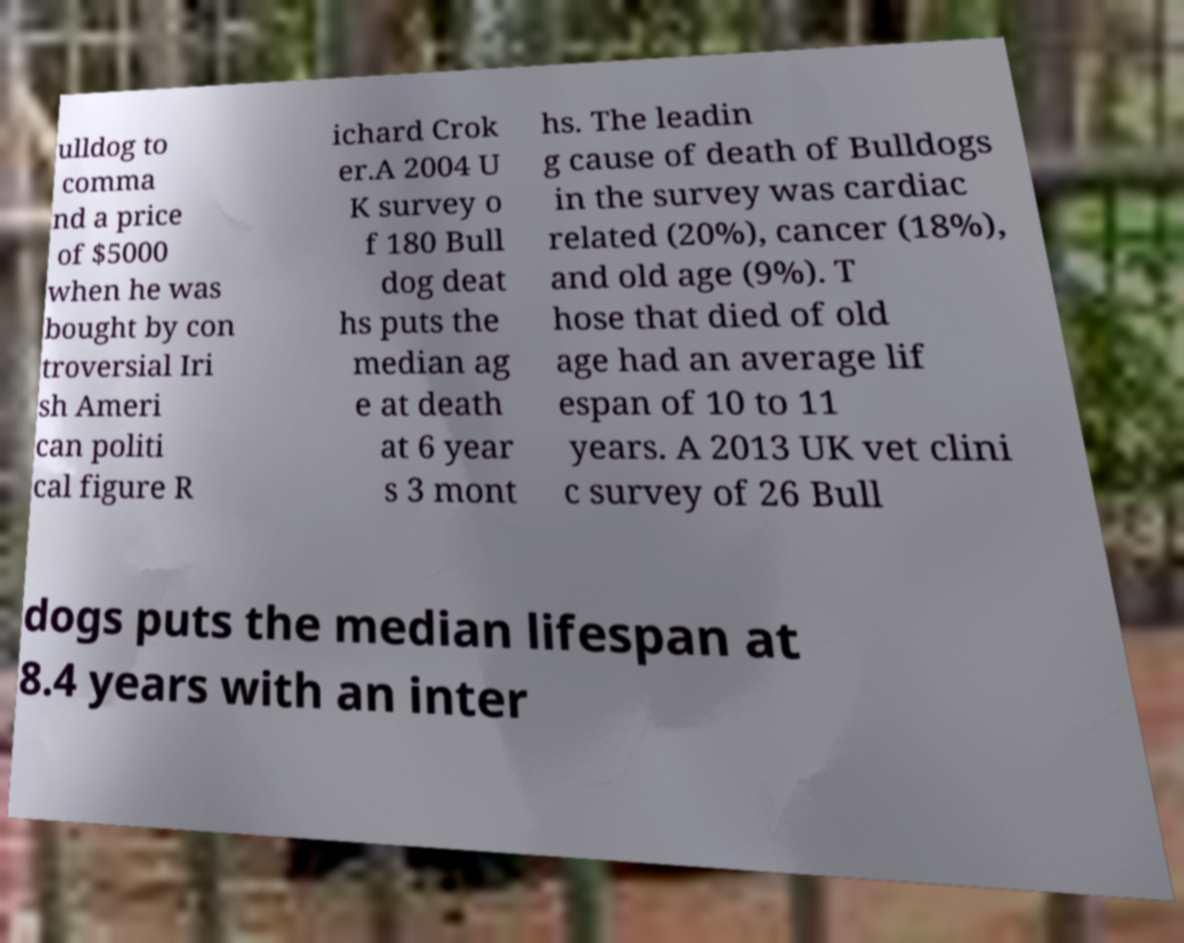Please read and relay the text visible in this image. What does it say? ulldog to comma nd a price of $5000 when he was bought by con troversial Iri sh Ameri can politi cal figure R ichard Crok er.A 2004 U K survey o f 180 Bull dog deat hs puts the median ag e at death at 6 year s 3 mont hs. The leadin g cause of death of Bulldogs in the survey was cardiac related (20%), cancer (18%), and old age (9%). T hose that died of old age had an average lif espan of 10 to 11 years. A 2013 UK vet clini c survey of 26 Bull dogs puts the median lifespan at 8.4 years with an inter 